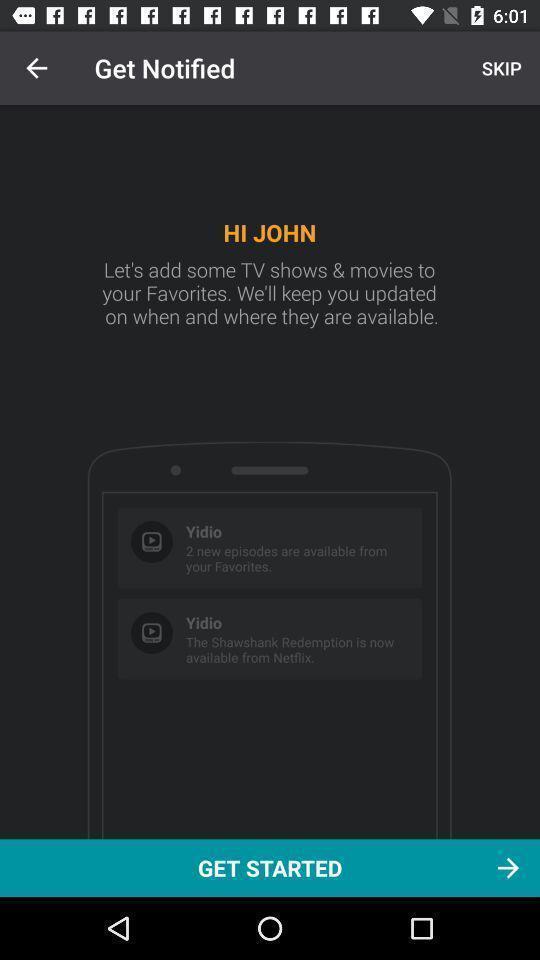Give me a narrative description of this picture. Welcome page for streaming app. 